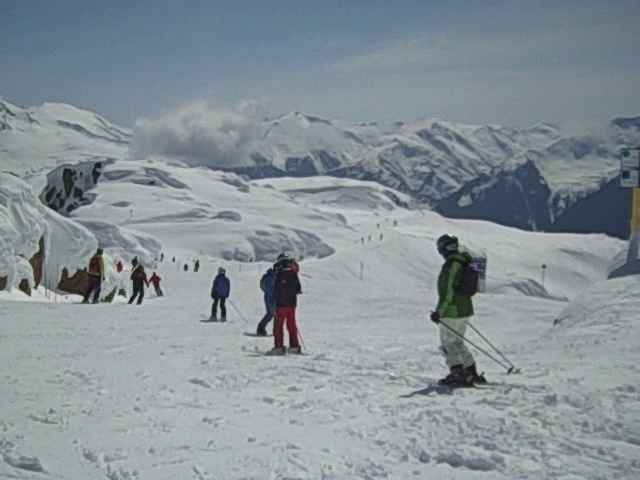Describe the objects in this image and their specific colors. I can see people in gray, black, and darkgreen tones, people in gray, black, maroon, and darkgray tones, skis in gray, darkgray, and black tones, people in gray, black, darkgray, and darkgreen tones, and backpack in gray and black tones in this image. 